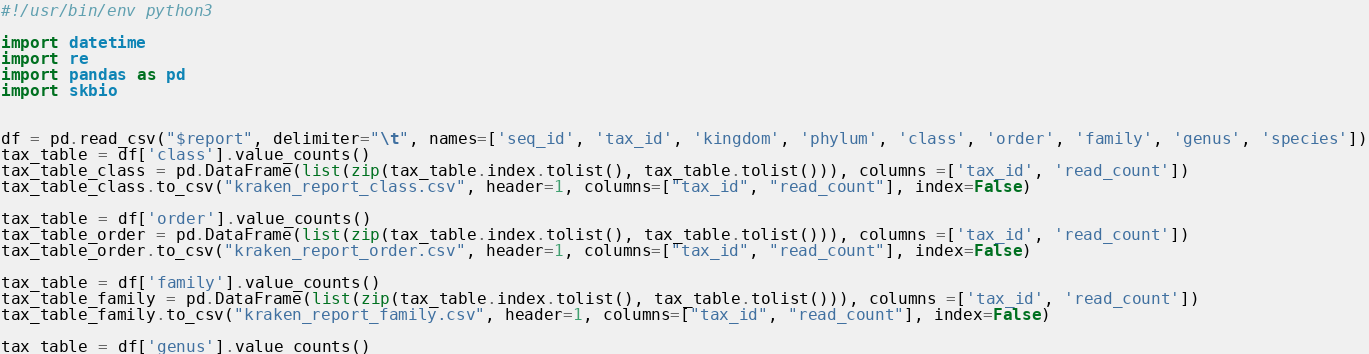Convert code to text. <code><loc_0><loc_0><loc_500><loc_500><_Python_>#!/usr/bin/env python3

import datetime
import re
import pandas as pd
import skbio


df = pd.read_csv("$report", delimiter="\t", names=['seq_id', 'tax_id', 'kingdom', 'phylum', 'class', 'order', 'family', 'genus', 'species'])
tax_table = df['class'].value_counts()
tax_table_class = pd.DataFrame(list(zip(tax_table.index.tolist(), tax_table.tolist())), columns =['tax_id', 'read_count'])
tax_table_class.to_csv("kraken_report_class.csv", header=1, columns=["tax_id", "read_count"], index=False)

tax_table = df['order'].value_counts()
tax_table_order = pd.DataFrame(list(zip(tax_table.index.tolist(), tax_table.tolist())), columns =['tax_id', 'read_count'])
tax_table_order.to_csv("kraken_report_order.csv", header=1, columns=["tax_id", "read_count"], index=False)

tax_table = df['family'].value_counts()
tax_table_family = pd.DataFrame(list(zip(tax_table.index.tolist(), tax_table.tolist())), columns =['tax_id', 'read_count'])
tax_table_family.to_csv("kraken_report_family.csv", header=1, columns=["tax_id", "read_count"], index=False)

tax_table = df['genus'].value_counts()</code> 